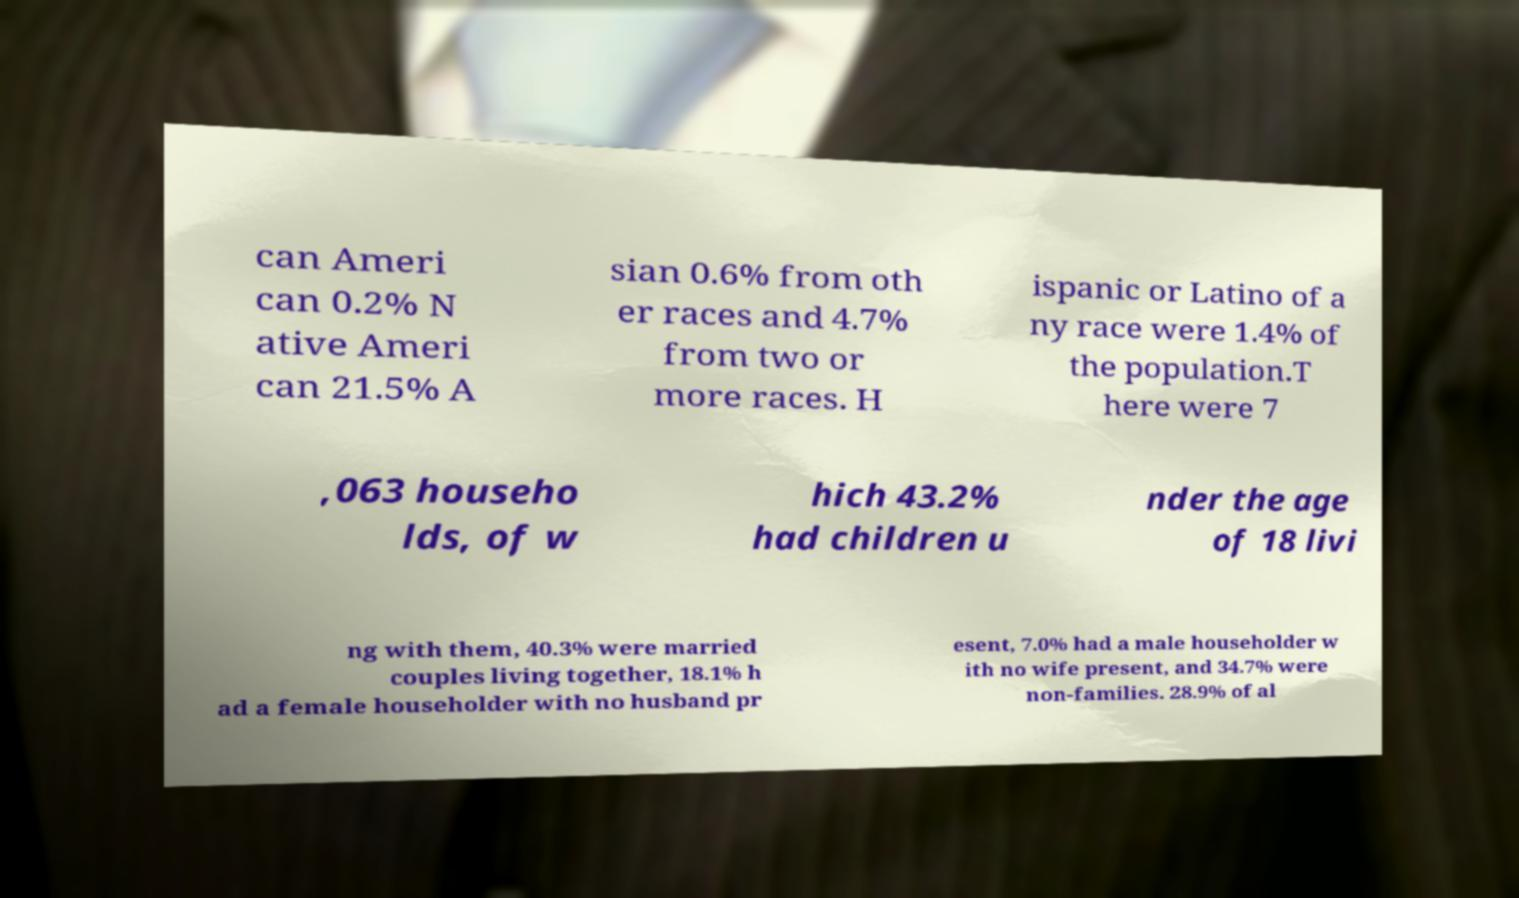Can you read and provide the text displayed in the image?This photo seems to have some interesting text. Can you extract and type it out for me? can Ameri can 0.2% N ative Ameri can 21.5% A sian 0.6% from oth er races and 4.7% from two or more races. H ispanic or Latino of a ny race were 1.4% of the population.T here were 7 ,063 househo lds, of w hich 43.2% had children u nder the age of 18 livi ng with them, 40.3% were married couples living together, 18.1% h ad a female householder with no husband pr esent, 7.0% had a male householder w ith no wife present, and 34.7% were non-families. 28.9% of al 